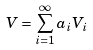Convert formula to latex. <formula><loc_0><loc_0><loc_500><loc_500>V = \sum _ { i = 1 } ^ { \infty } a _ { i } V _ { i }</formula> 